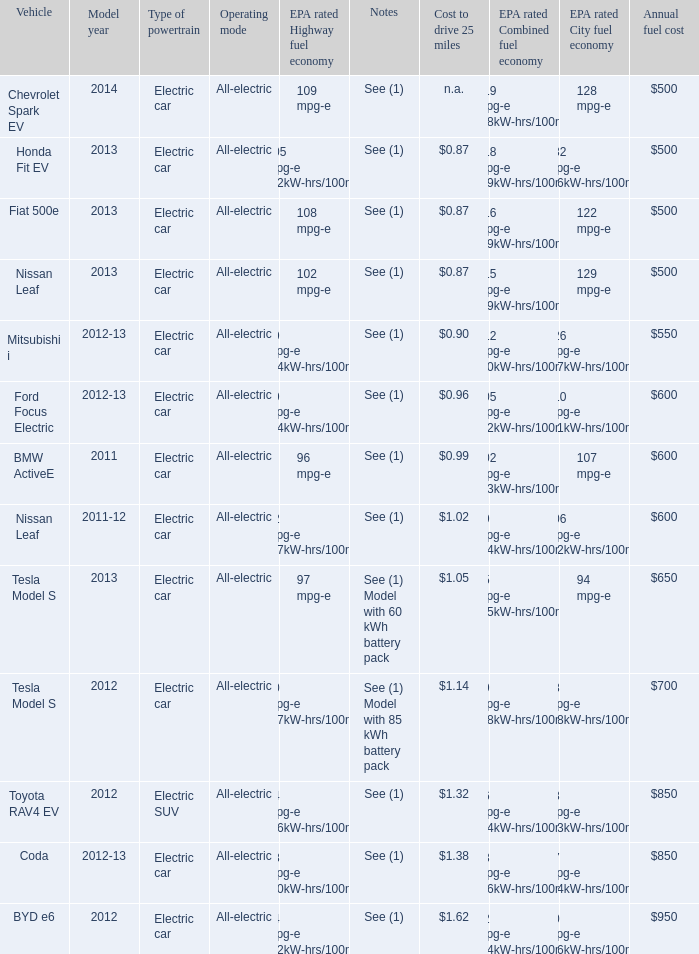What is the epa highway fuel economy for an electric suv? 74 mpg-e (46kW-hrs/100mi). 